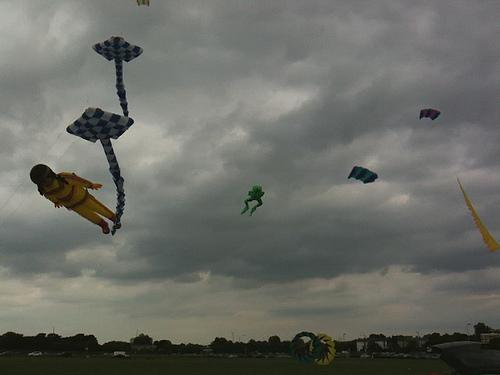Comment on the level of the clouds in the sky of the image. Several clouds are present in the image, some light and fluffy white clouds, and others appearing as heavy, more saturated grey clouds. Write a short sentence about the predominant kites' patterns and colors in the picture. The kites featured in the image exhibit diverse patterns and colors, ranging from checkered designs to bright hues of blue, green, and yellow. Provide a brief description of the primary elements in the image. Various kites can be seen flying in a sky filled with white clouds, while heavy clouds and green trees are visible in the distance. In a sentence, describe the state of the sky in the image. The sky has a mix of white clouds, heavy clouds, and pockets of blue, giving it a cloudy, soggy appearance. Write a one-liner about the weather portrayed in the image. The weather in the picture appears overcast and cloudy, with a mix of white and grey clouds filling the sky. In a sentence, characterize the general ambiance of the scene in the image. The atmosphere in the picture is lively, with numerous kites soaring against the cloudy sky, and a hint of greenery in the background. Highlight the scenery in the image, including the vegetation and atmosphere. Amidst a backdrop of heavy clouds and white clouds in the blue sky, various kites float in the air with green trees in the far distance. Describe the kites in the picture along with other elements surrounding them. The image showcases a variety of kites, including checkered, colorful, and uniquely designed ones, soaring through a cloudy sky above green trees in the distance. Mention the different types/colors of kites seen in the picture. The kites include black and white checkered, blue, green, yellow, red and blue, long and yellow, and a double checkered blue and white kite. Summarize the scene in the picture with an emphasis on the sky. In the image, a variety of colorful kites glide through a grey, cloudy sky with patches of blue and green trees in the distance. 